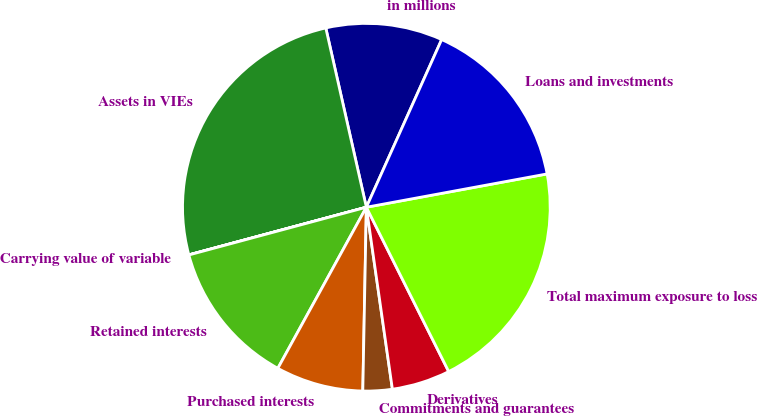Convert chart. <chart><loc_0><loc_0><loc_500><loc_500><pie_chart><fcel>in millions<fcel>Assets in VIEs<fcel>Carrying value of variable<fcel>Retained interests<fcel>Purchased interests<fcel>Commitments and guarantees<fcel>Derivatives<fcel>Total maximum exposure to loss<fcel>Loans and investments<nl><fcel>10.26%<fcel>25.63%<fcel>0.01%<fcel>12.82%<fcel>7.69%<fcel>2.57%<fcel>5.13%<fcel>20.51%<fcel>15.38%<nl></chart> 